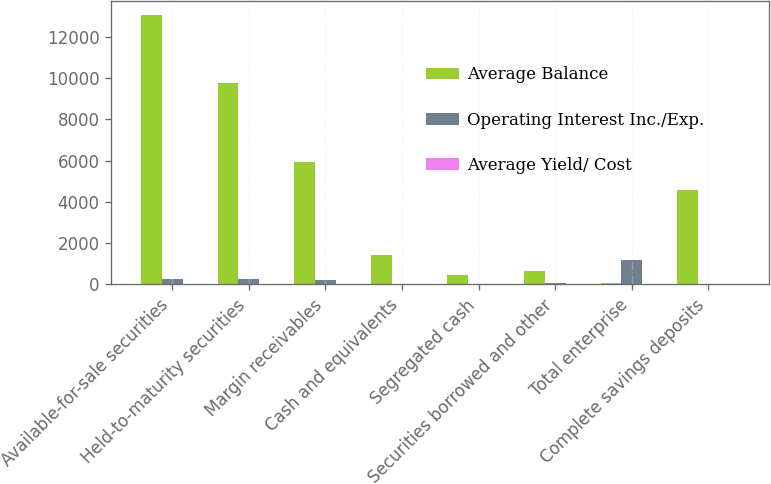Convert chart. <chart><loc_0><loc_0><loc_500><loc_500><stacked_bar_chart><ecel><fcel>Available-for-sale securities<fcel>Held-to-maturity securities<fcel>Margin receivables<fcel>Cash and equivalents<fcel>Segregated cash<fcel>Securities borrowed and other<fcel>Total enterprise<fcel>Complete savings deposits<nl><fcel>Average Balance<fcel>13074.2<fcel>9772.3<fcel>5928.9<fcel>1433.8<fcel>457.3<fcel>656.5<fcel>50.9<fcel>4581.6<nl><fcel>Operating Interest Inc./Exp.<fcel>279.9<fcel>255.4<fcel>224<fcel>2.9<fcel>0.4<fcel>50.9<fcel>1208.1<fcel>0.4<nl><fcel>Average Yield/ Cost<fcel>2.14<fcel>2.61<fcel>3.78<fcel>0.2<fcel>0.1<fcel>7.76<fcel>2.95<fcel>0.01<nl></chart> 